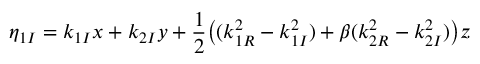Convert formula to latex. <formula><loc_0><loc_0><loc_500><loc_500>\eta _ { 1 I } = k _ { 1 I } x + k _ { 2 I } y + \frac { 1 } { 2 } \left ( ( k _ { 1 R } ^ { 2 } - k _ { 1 I } ^ { 2 } ) + \beta ( k _ { 2 R } ^ { 2 } - k _ { 2 I } ^ { 2 } ) \right ) z</formula> 